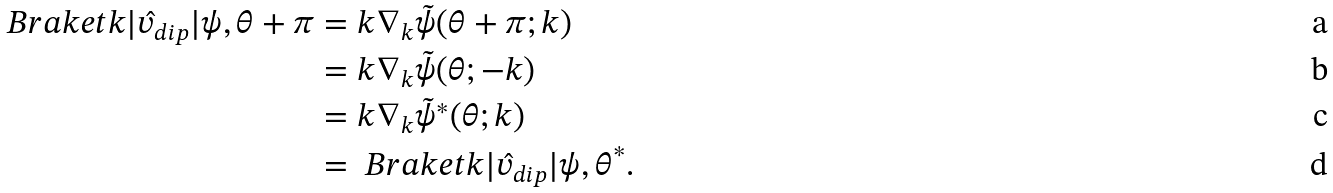<formula> <loc_0><loc_0><loc_500><loc_500>\ B r a k e t { k | \hat { v } _ { d i p } | \psi , \theta + \pi } & = k \nabla _ { k } \tilde { \psi } ( \theta + \pi ; k ) \\ & = k \nabla _ { k } \tilde { \psi } ( \theta ; - k ) \\ & = k \nabla _ { k } \tilde { \psi } ^ { * } ( \theta ; k ) \\ & = \ B r a k e t { k | \hat { v } _ { d i p } | \psi , \theta } ^ { * } .</formula> 